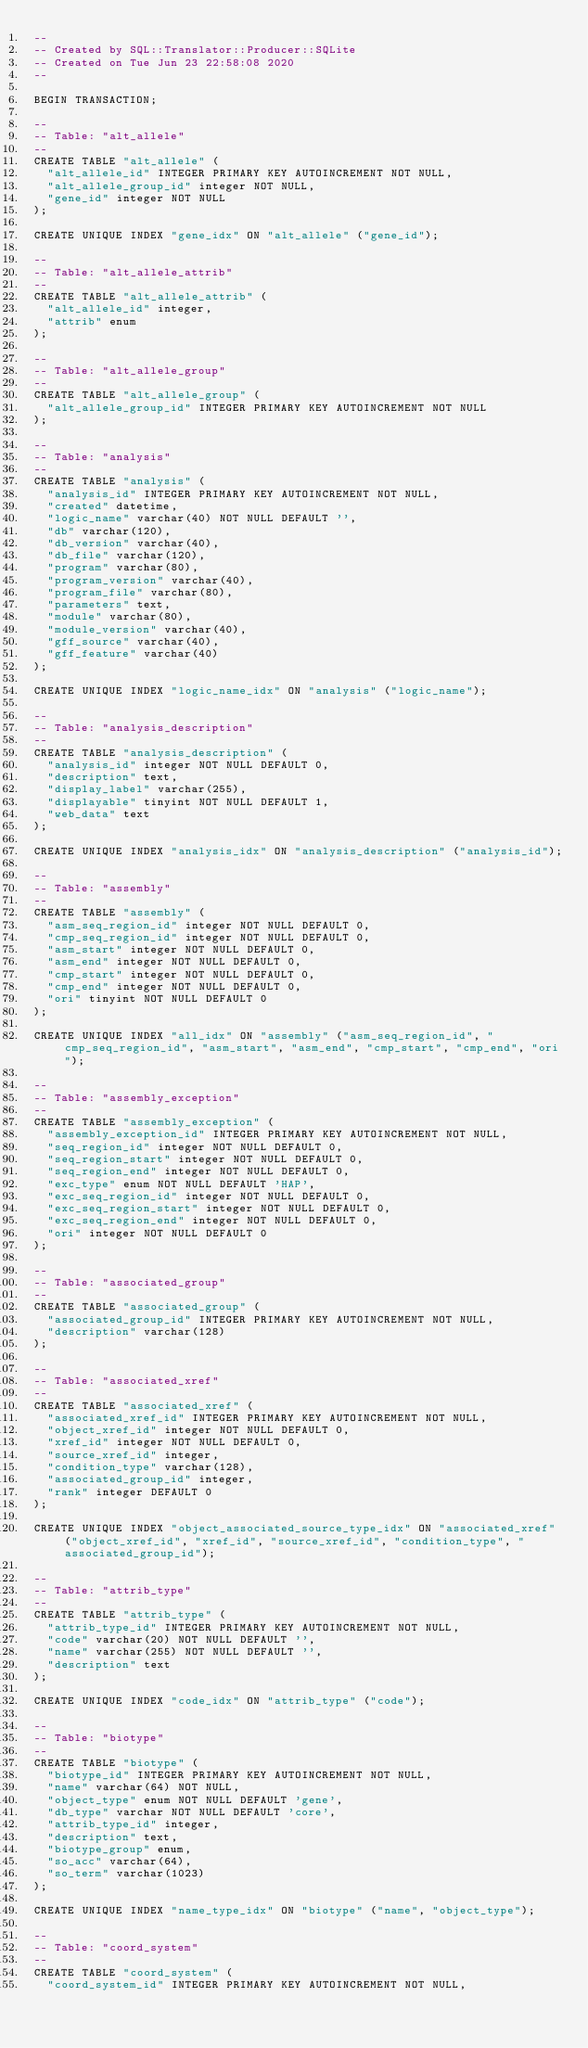Convert code to text. <code><loc_0><loc_0><loc_500><loc_500><_SQL_>-- 
-- Created by SQL::Translator::Producer::SQLite
-- Created on Tue Jun 23 22:58:08 2020
-- 

BEGIN TRANSACTION;

--
-- Table: "alt_allele"
--
CREATE TABLE "alt_allele" (
  "alt_allele_id" INTEGER PRIMARY KEY AUTOINCREMENT NOT NULL,
  "alt_allele_group_id" integer NOT NULL,
  "gene_id" integer NOT NULL
);

CREATE UNIQUE INDEX "gene_idx" ON "alt_allele" ("gene_id");

--
-- Table: "alt_allele_attrib"
--
CREATE TABLE "alt_allele_attrib" (
  "alt_allele_id" integer,
  "attrib" enum
);

--
-- Table: "alt_allele_group"
--
CREATE TABLE "alt_allele_group" (
  "alt_allele_group_id" INTEGER PRIMARY KEY AUTOINCREMENT NOT NULL
);

--
-- Table: "analysis"
--
CREATE TABLE "analysis" (
  "analysis_id" INTEGER PRIMARY KEY AUTOINCREMENT NOT NULL,
  "created" datetime,
  "logic_name" varchar(40) NOT NULL DEFAULT '',
  "db" varchar(120),
  "db_version" varchar(40),
  "db_file" varchar(120),
  "program" varchar(80),
  "program_version" varchar(40),
  "program_file" varchar(80),
  "parameters" text,
  "module" varchar(80),
  "module_version" varchar(40),
  "gff_source" varchar(40),
  "gff_feature" varchar(40)
);

CREATE UNIQUE INDEX "logic_name_idx" ON "analysis" ("logic_name");

--
-- Table: "analysis_description"
--
CREATE TABLE "analysis_description" (
  "analysis_id" integer NOT NULL DEFAULT 0,
  "description" text,
  "display_label" varchar(255),
  "displayable" tinyint NOT NULL DEFAULT 1,
  "web_data" text
);

CREATE UNIQUE INDEX "analysis_idx" ON "analysis_description" ("analysis_id");

--
-- Table: "assembly"
--
CREATE TABLE "assembly" (
  "asm_seq_region_id" integer NOT NULL DEFAULT 0,
  "cmp_seq_region_id" integer NOT NULL DEFAULT 0,
  "asm_start" integer NOT NULL DEFAULT 0,
  "asm_end" integer NOT NULL DEFAULT 0,
  "cmp_start" integer NOT NULL DEFAULT 0,
  "cmp_end" integer NOT NULL DEFAULT 0,
  "ori" tinyint NOT NULL DEFAULT 0
);

CREATE UNIQUE INDEX "all_idx" ON "assembly" ("asm_seq_region_id", "cmp_seq_region_id", "asm_start", "asm_end", "cmp_start", "cmp_end", "ori");

--
-- Table: "assembly_exception"
--
CREATE TABLE "assembly_exception" (
  "assembly_exception_id" INTEGER PRIMARY KEY AUTOINCREMENT NOT NULL,
  "seq_region_id" integer NOT NULL DEFAULT 0,
  "seq_region_start" integer NOT NULL DEFAULT 0,
  "seq_region_end" integer NOT NULL DEFAULT 0,
  "exc_type" enum NOT NULL DEFAULT 'HAP',
  "exc_seq_region_id" integer NOT NULL DEFAULT 0,
  "exc_seq_region_start" integer NOT NULL DEFAULT 0,
  "exc_seq_region_end" integer NOT NULL DEFAULT 0,
  "ori" integer NOT NULL DEFAULT 0
);

--
-- Table: "associated_group"
--
CREATE TABLE "associated_group" (
  "associated_group_id" INTEGER PRIMARY KEY AUTOINCREMENT NOT NULL,
  "description" varchar(128)
);

--
-- Table: "associated_xref"
--
CREATE TABLE "associated_xref" (
  "associated_xref_id" INTEGER PRIMARY KEY AUTOINCREMENT NOT NULL,
  "object_xref_id" integer NOT NULL DEFAULT 0,
  "xref_id" integer NOT NULL DEFAULT 0,
  "source_xref_id" integer,
  "condition_type" varchar(128),
  "associated_group_id" integer,
  "rank" integer DEFAULT 0
);

CREATE UNIQUE INDEX "object_associated_source_type_idx" ON "associated_xref" ("object_xref_id", "xref_id", "source_xref_id", "condition_type", "associated_group_id");

--
-- Table: "attrib_type"
--
CREATE TABLE "attrib_type" (
  "attrib_type_id" INTEGER PRIMARY KEY AUTOINCREMENT NOT NULL,
  "code" varchar(20) NOT NULL DEFAULT '',
  "name" varchar(255) NOT NULL DEFAULT '',
  "description" text
);

CREATE UNIQUE INDEX "code_idx" ON "attrib_type" ("code");

--
-- Table: "biotype"
--
CREATE TABLE "biotype" (
  "biotype_id" INTEGER PRIMARY KEY AUTOINCREMENT NOT NULL,
  "name" varchar(64) NOT NULL,
  "object_type" enum NOT NULL DEFAULT 'gene',
  "db_type" varchar NOT NULL DEFAULT 'core',
  "attrib_type_id" integer,
  "description" text,
  "biotype_group" enum,
  "so_acc" varchar(64),
  "so_term" varchar(1023)
);

CREATE UNIQUE INDEX "name_type_idx" ON "biotype" ("name", "object_type");

--
-- Table: "coord_system"
--
CREATE TABLE "coord_system" (
  "coord_system_id" INTEGER PRIMARY KEY AUTOINCREMENT NOT NULL,</code> 